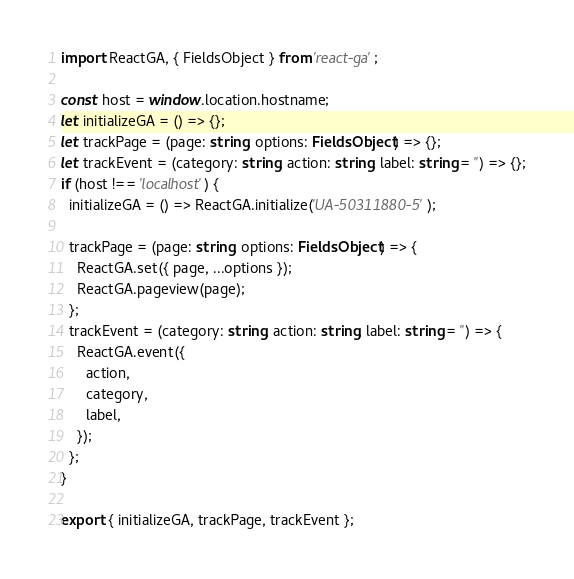Convert code to text. <code><loc_0><loc_0><loc_500><loc_500><_TypeScript_>import ReactGA, { FieldsObject } from 'react-ga';

const host = window.location.hostname;
let initializeGA = () => {};
let trackPage = (page: string, options: FieldsObject) => {};
let trackEvent = (category: string, action: string, label: string = '') => {};
if (host !== 'localhost') {
  initializeGA = () => ReactGA.initialize('UA-50311880-5');

  trackPage = (page: string, options: FieldsObject) => {
    ReactGA.set({ page, ...options });
    ReactGA.pageview(page);
  };
  trackEvent = (category: string, action: string, label: string = '') => {
    ReactGA.event({
      action,
      category,
      label,
    });
  };
}

export { initializeGA, trackPage, trackEvent };
</code> 